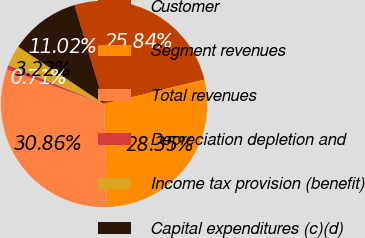Convert chart to OTSL. <chart><loc_0><loc_0><loc_500><loc_500><pie_chart><fcel>Customer<fcel>Segment revenues<fcel>Total revenues<fcel>Depreciation depletion and<fcel>Income tax provision (benefit)<fcel>Capital expenditures (c)(d)<nl><fcel>25.84%<fcel>28.35%<fcel>30.86%<fcel>0.71%<fcel>3.22%<fcel>11.02%<nl></chart> 